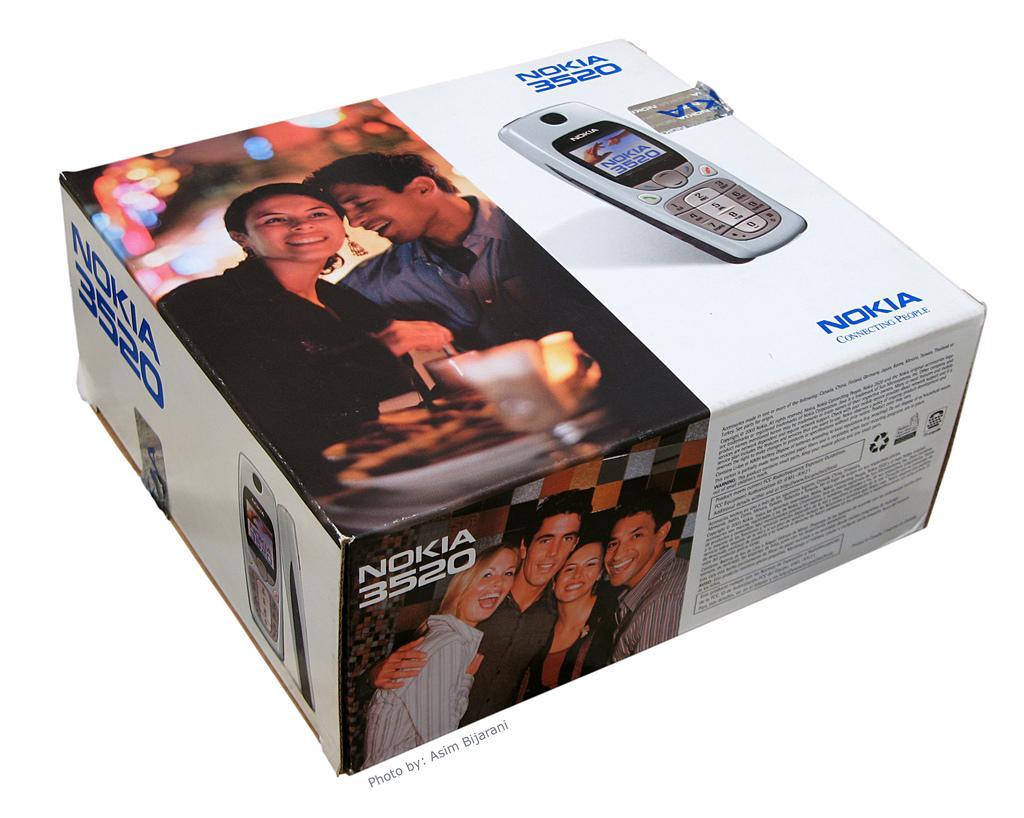In one or two sentences, can you explain what this image depicts? In this image we can see some pictures of a man, woman and a cellphone on the box. 